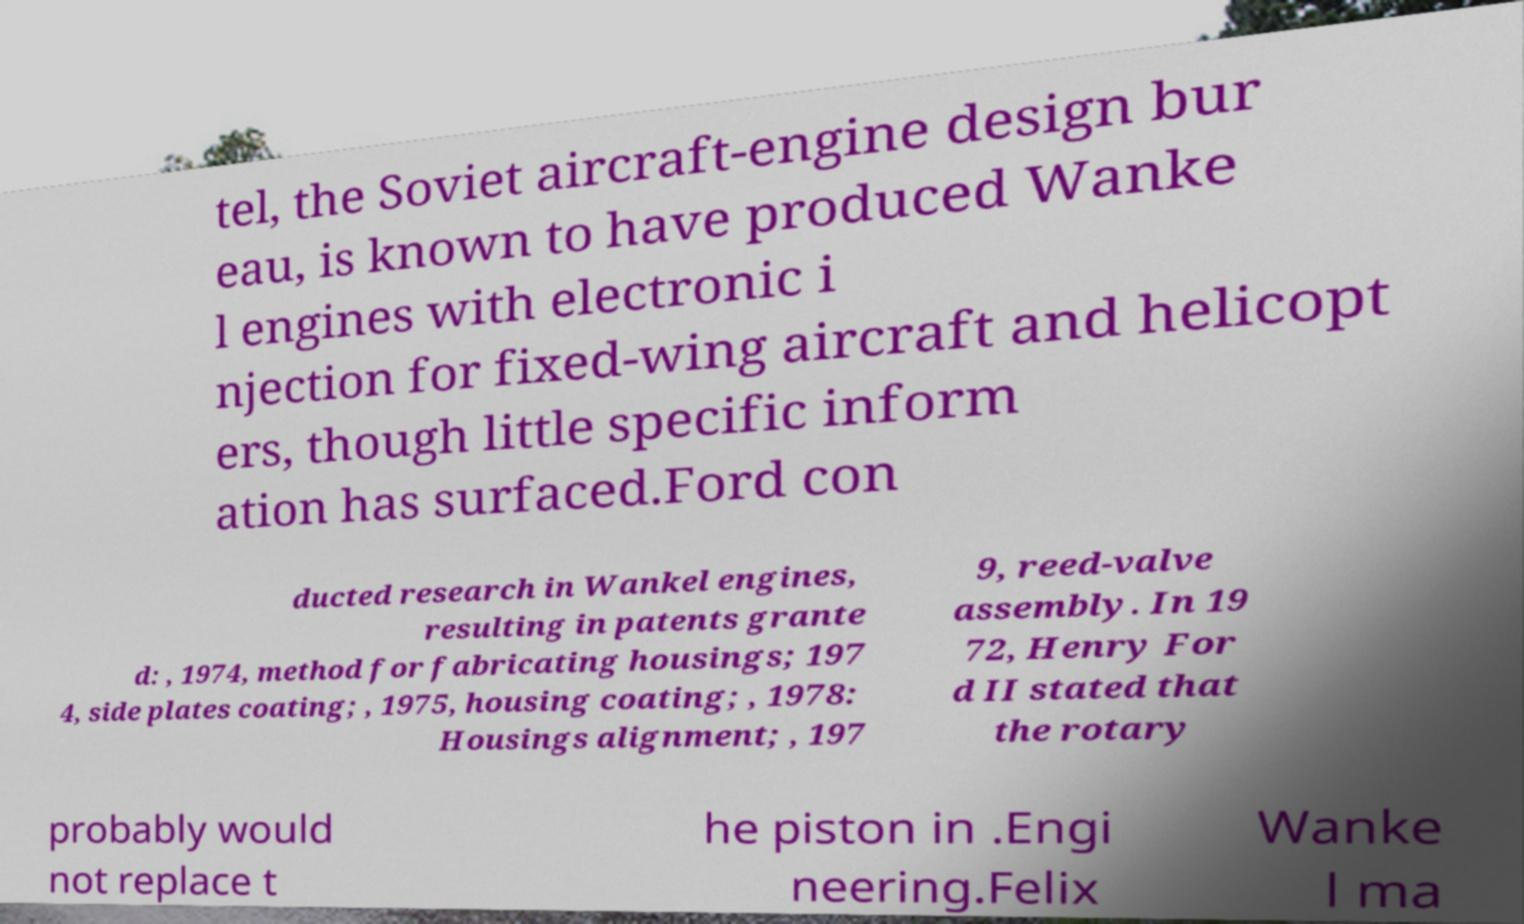There's text embedded in this image that I need extracted. Can you transcribe it verbatim? tel, the Soviet aircraft-engine design bur eau, is known to have produced Wanke l engines with electronic i njection for fixed-wing aircraft and helicopt ers, though little specific inform ation has surfaced.Ford con ducted research in Wankel engines, resulting in patents grante d: , 1974, method for fabricating housings; 197 4, side plates coating; , 1975, housing coating; , 1978: Housings alignment; , 197 9, reed-valve assembly. In 19 72, Henry For d II stated that the rotary probably would not replace t he piston in .Engi neering.Felix Wanke l ma 